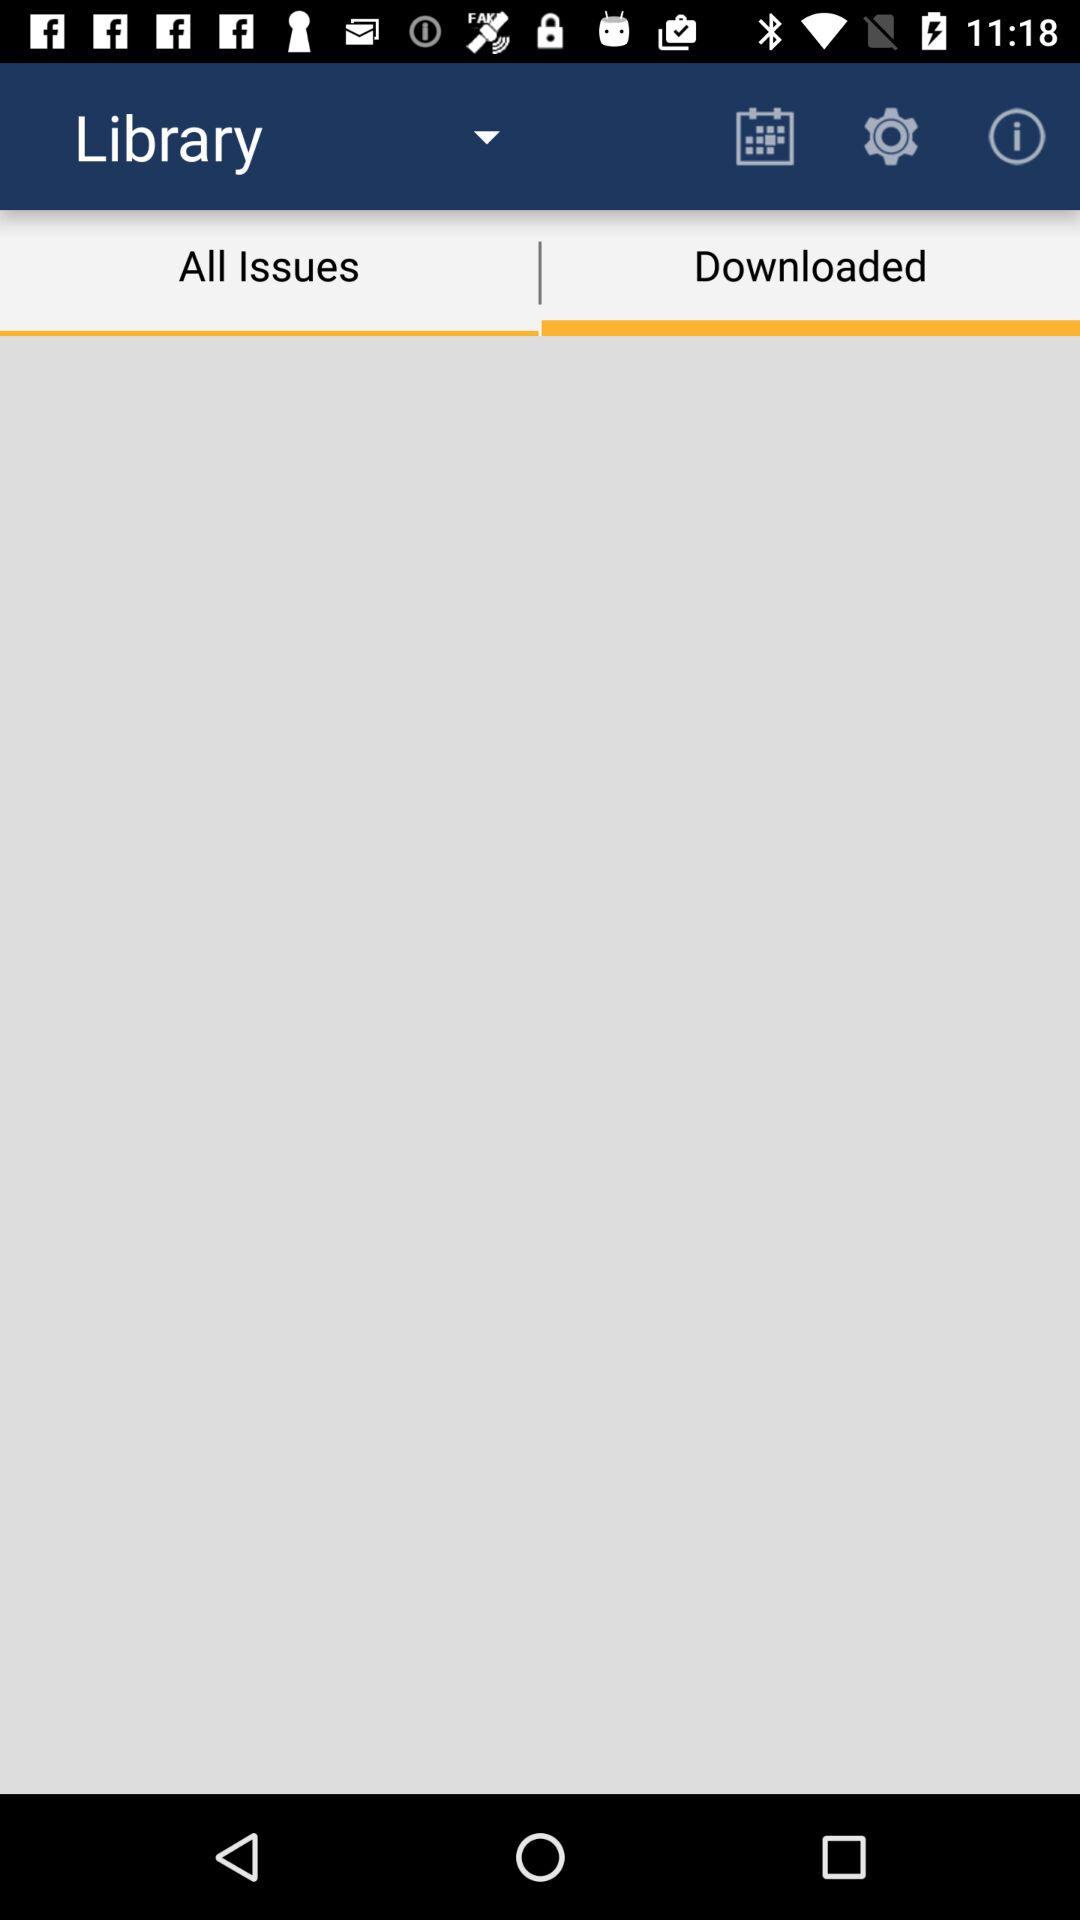Which tab is selected? The selected tab is "Downloaded". 